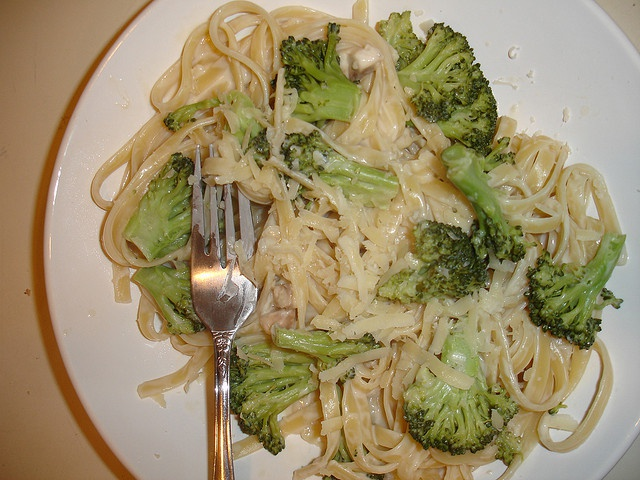Describe the objects in this image and their specific colors. I can see dining table in brown, gray, and tan tones, broccoli in brown, olive, and black tones, fork in brown, darkgray, gray, and maroon tones, broccoli in brown, olive, and black tones, and broccoli in brown, olive, black, and tan tones in this image. 